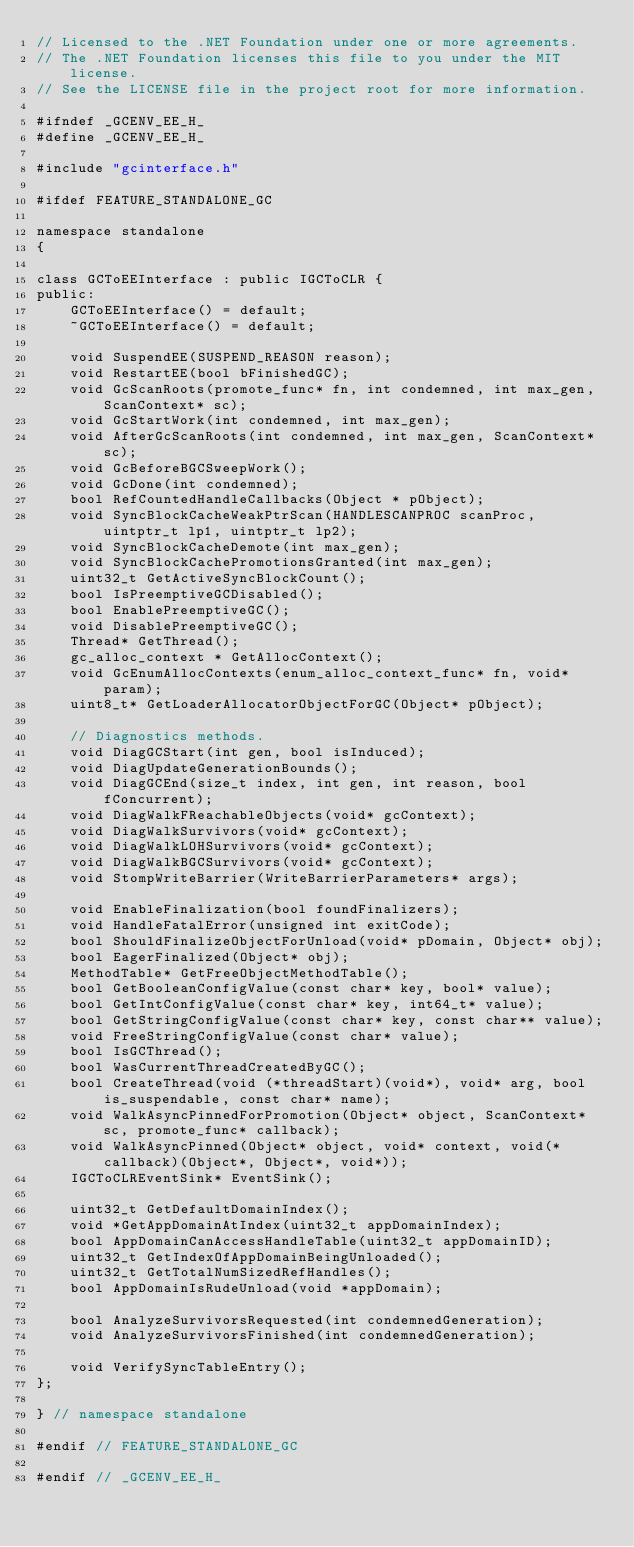Convert code to text. <code><loc_0><loc_0><loc_500><loc_500><_C_>// Licensed to the .NET Foundation under one or more agreements.
// The .NET Foundation licenses this file to you under the MIT license.
// See the LICENSE file in the project root for more information.

#ifndef _GCENV_EE_H_
#define _GCENV_EE_H_

#include "gcinterface.h"

#ifdef FEATURE_STANDALONE_GC

namespace standalone
{

class GCToEEInterface : public IGCToCLR {
public:
    GCToEEInterface() = default;
    ~GCToEEInterface() = default;

    void SuspendEE(SUSPEND_REASON reason);
    void RestartEE(bool bFinishedGC);
    void GcScanRoots(promote_func* fn, int condemned, int max_gen, ScanContext* sc);
    void GcStartWork(int condemned, int max_gen);
    void AfterGcScanRoots(int condemned, int max_gen, ScanContext* sc);
    void GcBeforeBGCSweepWork();
    void GcDone(int condemned);
    bool RefCountedHandleCallbacks(Object * pObject);
    void SyncBlockCacheWeakPtrScan(HANDLESCANPROC scanProc, uintptr_t lp1, uintptr_t lp2);
    void SyncBlockCacheDemote(int max_gen);
    void SyncBlockCachePromotionsGranted(int max_gen);
    uint32_t GetActiveSyncBlockCount();
    bool IsPreemptiveGCDisabled();
    bool EnablePreemptiveGC();
    void DisablePreemptiveGC();
    Thread* GetThread();
    gc_alloc_context * GetAllocContext();
    void GcEnumAllocContexts(enum_alloc_context_func* fn, void* param);
    uint8_t* GetLoaderAllocatorObjectForGC(Object* pObject);

    // Diagnostics methods.
    void DiagGCStart(int gen, bool isInduced);
    void DiagUpdateGenerationBounds();
    void DiagGCEnd(size_t index, int gen, int reason, bool fConcurrent);
    void DiagWalkFReachableObjects(void* gcContext);
    void DiagWalkSurvivors(void* gcContext);
    void DiagWalkLOHSurvivors(void* gcContext);
    void DiagWalkBGCSurvivors(void* gcContext);
    void StompWriteBarrier(WriteBarrierParameters* args);

    void EnableFinalization(bool foundFinalizers);
    void HandleFatalError(unsigned int exitCode);
    bool ShouldFinalizeObjectForUnload(void* pDomain, Object* obj);
    bool EagerFinalized(Object* obj);
    MethodTable* GetFreeObjectMethodTable();
    bool GetBooleanConfigValue(const char* key, bool* value);
    bool GetIntConfigValue(const char* key, int64_t* value);
    bool GetStringConfigValue(const char* key, const char** value);
    void FreeStringConfigValue(const char* value);
    bool IsGCThread();
    bool WasCurrentThreadCreatedByGC();
    bool CreateThread(void (*threadStart)(void*), void* arg, bool is_suspendable, const char* name);
    void WalkAsyncPinnedForPromotion(Object* object, ScanContext* sc, promote_func* callback);
    void WalkAsyncPinned(Object* object, void* context, void(*callback)(Object*, Object*, void*));
    IGCToCLREventSink* EventSink();

    uint32_t GetDefaultDomainIndex();
    void *GetAppDomainAtIndex(uint32_t appDomainIndex);
    bool AppDomainCanAccessHandleTable(uint32_t appDomainID);
    uint32_t GetIndexOfAppDomainBeingUnloaded();
    uint32_t GetTotalNumSizedRefHandles();
    bool AppDomainIsRudeUnload(void *appDomain);

    bool AnalyzeSurvivorsRequested(int condemnedGeneration);
    void AnalyzeSurvivorsFinished(int condemnedGeneration);

    void VerifySyncTableEntry();
};

} // namespace standalone

#endif // FEATURE_STANDALONE_GC

#endif // _GCENV_EE_H_
</code> 